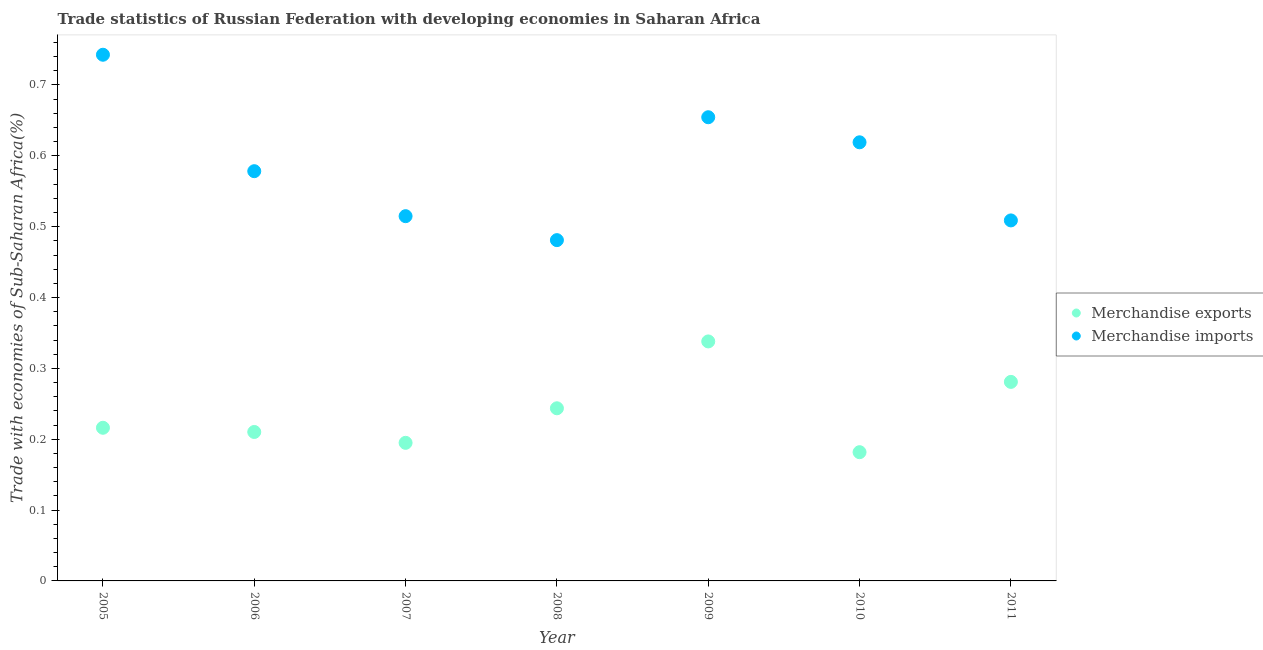How many different coloured dotlines are there?
Ensure brevity in your answer.  2. Is the number of dotlines equal to the number of legend labels?
Your answer should be compact. Yes. What is the merchandise exports in 2005?
Provide a short and direct response. 0.22. Across all years, what is the maximum merchandise imports?
Keep it short and to the point. 0.74. Across all years, what is the minimum merchandise imports?
Provide a short and direct response. 0.48. In which year was the merchandise exports minimum?
Provide a short and direct response. 2010. What is the total merchandise exports in the graph?
Provide a short and direct response. 1.67. What is the difference between the merchandise imports in 2006 and that in 2008?
Your answer should be compact. 0.1. What is the difference between the merchandise imports in 2011 and the merchandise exports in 2009?
Provide a succinct answer. 0.17. What is the average merchandise exports per year?
Provide a succinct answer. 0.24. In the year 2005, what is the difference between the merchandise exports and merchandise imports?
Provide a short and direct response. -0.53. In how many years, is the merchandise imports greater than 0.12000000000000001 %?
Provide a short and direct response. 7. What is the ratio of the merchandise exports in 2006 to that in 2008?
Provide a short and direct response. 0.86. Is the merchandise exports in 2006 less than that in 2008?
Your answer should be compact. Yes. Is the difference between the merchandise imports in 2007 and 2011 greater than the difference between the merchandise exports in 2007 and 2011?
Your response must be concise. Yes. What is the difference between the highest and the second highest merchandise exports?
Offer a very short reply. 0.06. What is the difference between the highest and the lowest merchandise exports?
Provide a short and direct response. 0.16. Is the sum of the merchandise exports in 2007 and 2009 greater than the maximum merchandise imports across all years?
Offer a terse response. No. Does the merchandise imports monotonically increase over the years?
Make the answer very short. No. Is the merchandise imports strictly greater than the merchandise exports over the years?
Give a very brief answer. Yes. Does the graph contain any zero values?
Offer a very short reply. No. How many legend labels are there?
Make the answer very short. 2. What is the title of the graph?
Make the answer very short. Trade statistics of Russian Federation with developing economies in Saharan Africa. What is the label or title of the Y-axis?
Ensure brevity in your answer.  Trade with economies of Sub-Saharan Africa(%). What is the Trade with economies of Sub-Saharan Africa(%) of Merchandise exports in 2005?
Provide a short and direct response. 0.22. What is the Trade with economies of Sub-Saharan Africa(%) of Merchandise imports in 2005?
Your answer should be compact. 0.74. What is the Trade with economies of Sub-Saharan Africa(%) in Merchandise exports in 2006?
Provide a succinct answer. 0.21. What is the Trade with economies of Sub-Saharan Africa(%) of Merchandise imports in 2006?
Keep it short and to the point. 0.58. What is the Trade with economies of Sub-Saharan Africa(%) of Merchandise exports in 2007?
Make the answer very short. 0.19. What is the Trade with economies of Sub-Saharan Africa(%) of Merchandise imports in 2007?
Keep it short and to the point. 0.51. What is the Trade with economies of Sub-Saharan Africa(%) in Merchandise exports in 2008?
Your response must be concise. 0.24. What is the Trade with economies of Sub-Saharan Africa(%) of Merchandise imports in 2008?
Your answer should be very brief. 0.48. What is the Trade with economies of Sub-Saharan Africa(%) of Merchandise exports in 2009?
Your response must be concise. 0.34. What is the Trade with economies of Sub-Saharan Africa(%) of Merchandise imports in 2009?
Offer a terse response. 0.65. What is the Trade with economies of Sub-Saharan Africa(%) in Merchandise exports in 2010?
Provide a succinct answer. 0.18. What is the Trade with economies of Sub-Saharan Africa(%) in Merchandise imports in 2010?
Provide a succinct answer. 0.62. What is the Trade with economies of Sub-Saharan Africa(%) in Merchandise exports in 2011?
Offer a very short reply. 0.28. What is the Trade with economies of Sub-Saharan Africa(%) in Merchandise imports in 2011?
Your answer should be very brief. 0.51. Across all years, what is the maximum Trade with economies of Sub-Saharan Africa(%) in Merchandise exports?
Provide a short and direct response. 0.34. Across all years, what is the maximum Trade with economies of Sub-Saharan Africa(%) of Merchandise imports?
Give a very brief answer. 0.74. Across all years, what is the minimum Trade with economies of Sub-Saharan Africa(%) of Merchandise exports?
Make the answer very short. 0.18. Across all years, what is the minimum Trade with economies of Sub-Saharan Africa(%) of Merchandise imports?
Offer a terse response. 0.48. What is the total Trade with economies of Sub-Saharan Africa(%) in Merchandise exports in the graph?
Offer a very short reply. 1.67. What is the total Trade with economies of Sub-Saharan Africa(%) in Merchandise imports in the graph?
Your response must be concise. 4.1. What is the difference between the Trade with economies of Sub-Saharan Africa(%) of Merchandise exports in 2005 and that in 2006?
Ensure brevity in your answer.  0.01. What is the difference between the Trade with economies of Sub-Saharan Africa(%) of Merchandise imports in 2005 and that in 2006?
Your response must be concise. 0.16. What is the difference between the Trade with economies of Sub-Saharan Africa(%) in Merchandise exports in 2005 and that in 2007?
Ensure brevity in your answer.  0.02. What is the difference between the Trade with economies of Sub-Saharan Africa(%) of Merchandise imports in 2005 and that in 2007?
Your response must be concise. 0.23. What is the difference between the Trade with economies of Sub-Saharan Africa(%) of Merchandise exports in 2005 and that in 2008?
Your answer should be compact. -0.03. What is the difference between the Trade with economies of Sub-Saharan Africa(%) in Merchandise imports in 2005 and that in 2008?
Your answer should be compact. 0.26. What is the difference between the Trade with economies of Sub-Saharan Africa(%) of Merchandise exports in 2005 and that in 2009?
Keep it short and to the point. -0.12. What is the difference between the Trade with economies of Sub-Saharan Africa(%) in Merchandise imports in 2005 and that in 2009?
Keep it short and to the point. 0.09. What is the difference between the Trade with economies of Sub-Saharan Africa(%) in Merchandise exports in 2005 and that in 2010?
Provide a short and direct response. 0.03. What is the difference between the Trade with economies of Sub-Saharan Africa(%) of Merchandise imports in 2005 and that in 2010?
Ensure brevity in your answer.  0.12. What is the difference between the Trade with economies of Sub-Saharan Africa(%) of Merchandise exports in 2005 and that in 2011?
Your answer should be very brief. -0.06. What is the difference between the Trade with economies of Sub-Saharan Africa(%) in Merchandise imports in 2005 and that in 2011?
Offer a terse response. 0.23. What is the difference between the Trade with economies of Sub-Saharan Africa(%) of Merchandise exports in 2006 and that in 2007?
Make the answer very short. 0.02. What is the difference between the Trade with economies of Sub-Saharan Africa(%) in Merchandise imports in 2006 and that in 2007?
Your answer should be compact. 0.06. What is the difference between the Trade with economies of Sub-Saharan Africa(%) in Merchandise exports in 2006 and that in 2008?
Make the answer very short. -0.03. What is the difference between the Trade with economies of Sub-Saharan Africa(%) in Merchandise imports in 2006 and that in 2008?
Give a very brief answer. 0.1. What is the difference between the Trade with economies of Sub-Saharan Africa(%) in Merchandise exports in 2006 and that in 2009?
Your answer should be compact. -0.13. What is the difference between the Trade with economies of Sub-Saharan Africa(%) of Merchandise imports in 2006 and that in 2009?
Your response must be concise. -0.08. What is the difference between the Trade with economies of Sub-Saharan Africa(%) of Merchandise exports in 2006 and that in 2010?
Provide a succinct answer. 0.03. What is the difference between the Trade with economies of Sub-Saharan Africa(%) of Merchandise imports in 2006 and that in 2010?
Offer a terse response. -0.04. What is the difference between the Trade with economies of Sub-Saharan Africa(%) in Merchandise exports in 2006 and that in 2011?
Provide a short and direct response. -0.07. What is the difference between the Trade with economies of Sub-Saharan Africa(%) of Merchandise imports in 2006 and that in 2011?
Provide a short and direct response. 0.07. What is the difference between the Trade with economies of Sub-Saharan Africa(%) of Merchandise exports in 2007 and that in 2008?
Your answer should be compact. -0.05. What is the difference between the Trade with economies of Sub-Saharan Africa(%) of Merchandise imports in 2007 and that in 2008?
Make the answer very short. 0.03. What is the difference between the Trade with economies of Sub-Saharan Africa(%) in Merchandise exports in 2007 and that in 2009?
Your answer should be very brief. -0.14. What is the difference between the Trade with economies of Sub-Saharan Africa(%) in Merchandise imports in 2007 and that in 2009?
Your answer should be very brief. -0.14. What is the difference between the Trade with economies of Sub-Saharan Africa(%) of Merchandise exports in 2007 and that in 2010?
Offer a terse response. 0.01. What is the difference between the Trade with economies of Sub-Saharan Africa(%) in Merchandise imports in 2007 and that in 2010?
Provide a succinct answer. -0.1. What is the difference between the Trade with economies of Sub-Saharan Africa(%) of Merchandise exports in 2007 and that in 2011?
Provide a succinct answer. -0.09. What is the difference between the Trade with economies of Sub-Saharan Africa(%) of Merchandise imports in 2007 and that in 2011?
Provide a succinct answer. 0.01. What is the difference between the Trade with economies of Sub-Saharan Africa(%) in Merchandise exports in 2008 and that in 2009?
Provide a succinct answer. -0.09. What is the difference between the Trade with economies of Sub-Saharan Africa(%) of Merchandise imports in 2008 and that in 2009?
Your answer should be very brief. -0.17. What is the difference between the Trade with economies of Sub-Saharan Africa(%) in Merchandise exports in 2008 and that in 2010?
Offer a very short reply. 0.06. What is the difference between the Trade with economies of Sub-Saharan Africa(%) in Merchandise imports in 2008 and that in 2010?
Offer a terse response. -0.14. What is the difference between the Trade with economies of Sub-Saharan Africa(%) in Merchandise exports in 2008 and that in 2011?
Give a very brief answer. -0.04. What is the difference between the Trade with economies of Sub-Saharan Africa(%) in Merchandise imports in 2008 and that in 2011?
Give a very brief answer. -0.03. What is the difference between the Trade with economies of Sub-Saharan Africa(%) in Merchandise exports in 2009 and that in 2010?
Keep it short and to the point. 0.16. What is the difference between the Trade with economies of Sub-Saharan Africa(%) in Merchandise imports in 2009 and that in 2010?
Your response must be concise. 0.04. What is the difference between the Trade with economies of Sub-Saharan Africa(%) in Merchandise exports in 2009 and that in 2011?
Ensure brevity in your answer.  0.06. What is the difference between the Trade with economies of Sub-Saharan Africa(%) of Merchandise imports in 2009 and that in 2011?
Offer a very short reply. 0.15. What is the difference between the Trade with economies of Sub-Saharan Africa(%) in Merchandise exports in 2010 and that in 2011?
Your response must be concise. -0.1. What is the difference between the Trade with economies of Sub-Saharan Africa(%) of Merchandise imports in 2010 and that in 2011?
Provide a short and direct response. 0.11. What is the difference between the Trade with economies of Sub-Saharan Africa(%) in Merchandise exports in 2005 and the Trade with economies of Sub-Saharan Africa(%) in Merchandise imports in 2006?
Offer a very short reply. -0.36. What is the difference between the Trade with economies of Sub-Saharan Africa(%) in Merchandise exports in 2005 and the Trade with economies of Sub-Saharan Africa(%) in Merchandise imports in 2007?
Provide a succinct answer. -0.3. What is the difference between the Trade with economies of Sub-Saharan Africa(%) in Merchandise exports in 2005 and the Trade with economies of Sub-Saharan Africa(%) in Merchandise imports in 2008?
Your answer should be compact. -0.26. What is the difference between the Trade with economies of Sub-Saharan Africa(%) of Merchandise exports in 2005 and the Trade with economies of Sub-Saharan Africa(%) of Merchandise imports in 2009?
Ensure brevity in your answer.  -0.44. What is the difference between the Trade with economies of Sub-Saharan Africa(%) in Merchandise exports in 2005 and the Trade with economies of Sub-Saharan Africa(%) in Merchandise imports in 2010?
Provide a succinct answer. -0.4. What is the difference between the Trade with economies of Sub-Saharan Africa(%) of Merchandise exports in 2005 and the Trade with economies of Sub-Saharan Africa(%) of Merchandise imports in 2011?
Your answer should be compact. -0.29. What is the difference between the Trade with economies of Sub-Saharan Africa(%) of Merchandise exports in 2006 and the Trade with economies of Sub-Saharan Africa(%) of Merchandise imports in 2007?
Offer a very short reply. -0.3. What is the difference between the Trade with economies of Sub-Saharan Africa(%) of Merchandise exports in 2006 and the Trade with economies of Sub-Saharan Africa(%) of Merchandise imports in 2008?
Your response must be concise. -0.27. What is the difference between the Trade with economies of Sub-Saharan Africa(%) in Merchandise exports in 2006 and the Trade with economies of Sub-Saharan Africa(%) in Merchandise imports in 2009?
Provide a short and direct response. -0.44. What is the difference between the Trade with economies of Sub-Saharan Africa(%) of Merchandise exports in 2006 and the Trade with economies of Sub-Saharan Africa(%) of Merchandise imports in 2010?
Your answer should be compact. -0.41. What is the difference between the Trade with economies of Sub-Saharan Africa(%) in Merchandise exports in 2006 and the Trade with economies of Sub-Saharan Africa(%) in Merchandise imports in 2011?
Provide a short and direct response. -0.3. What is the difference between the Trade with economies of Sub-Saharan Africa(%) in Merchandise exports in 2007 and the Trade with economies of Sub-Saharan Africa(%) in Merchandise imports in 2008?
Offer a terse response. -0.29. What is the difference between the Trade with economies of Sub-Saharan Africa(%) of Merchandise exports in 2007 and the Trade with economies of Sub-Saharan Africa(%) of Merchandise imports in 2009?
Provide a short and direct response. -0.46. What is the difference between the Trade with economies of Sub-Saharan Africa(%) in Merchandise exports in 2007 and the Trade with economies of Sub-Saharan Africa(%) in Merchandise imports in 2010?
Your response must be concise. -0.42. What is the difference between the Trade with economies of Sub-Saharan Africa(%) in Merchandise exports in 2007 and the Trade with economies of Sub-Saharan Africa(%) in Merchandise imports in 2011?
Keep it short and to the point. -0.31. What is the difference between the Trade with economies of Sub-Saharan Africa(%) of Merchandise exports in 2008 and the Trade with economies of Sub-Saharan Africa(%) of Merchandise imports in 2009?
Your answer should be very brief. -0.41. What is the difference between the Trade with economies of Sub-Saharan Africa(%) of Merchandise exports in 2008 and the Trade with economies of Sub-Saharan Africa(%) of Merchandise imports in 2010?
Provide a short and direct response. -0.38. What is the difference between the Trade with economies of Sub-Saharan Africa(%) in Merchandise exports in 2008 and the Trade with economies of Sub-Saharan Africa(%) in Merchandise imports in 2011?
Provide a succinct answer. -0.27. What is the difference between the Trade with economies of Sub-Saharan Africa(%) in Merchandise exports in 2009 and the Trade with economies of Sub-Saharan Africa(%) in Merchandise imports in 2010?
Your answer should be compact. -0.28. What is the difference between the Trade with economies of Sub-Saharan Africa(%) of Merchandise exports in 2009 and the Trade with economies of Sub-Saharan Africa(%) of Merchandise imports in 2011?
Give a very brief answer. -0.17. What is the difference between the Trade with economies of Sub-Saharan Africa(%) in Merchandise exports in 2010 and the Trade with economies of Sub-Saharan Africa(%) in Merchandise imports in 2011?
Give a very brief answer. -0.33. What is the average Trade with economies of Sub-Saharan Africa(%) in Merchandise exports per year?
Give a very brief answer. 0.24. What is the average Trade with economies of Sub-Saharan Africa(%) of Merchandise imports per year?
Ensure brevity in your answer.  0.59. In the year 2005, what is the difference between the Trade with economies of Sub-Saharan Africa(%) of Merchandise exports and Trade with economies of Sub-Saharan Africa(%) of Merchandise imports?
Provide a succinct answer. -0.53. In the year 2006, what is the difference between the Trade with economies of Sub-Saharan Africa(%) in Merchandise exports and Trade with economies of Sub-Saharan Africa(%) in Merchandise imports?
Provide a succinct answer. -0.37. In the year 2007, what is the difference between the Trade with economies of Sub-Saharan Africa(%) of Merchandise exports and Trade with economies of Sub-Saharan Africa(%) of Merchandise imports?
Your answer should be compact. -0.32. In the year 2008, what is the difference between the Trade with economies of Sub-Saharan Africa(%) in Merchandise exports and Trade with economies of Sub-Saharan Africa(%) in Merchandise imports?
Your answer should be very brief. -0.24. In the year 2009, what is the difference between the Trade with economies of Sub-Saharan Africa(%) of Merchandise exports and Trade with economies of Sub-Saharan Africa(%) of Merchandise imports?
Your answer should be very brief. -0.32. In the year 2010, what is the difference between the Trade with economies of Sub-Saharan Africa(%) of Merchandise exports and Trade with economies of Sub-Saharan Africa(%) of Merchandise imports?
Your answer should be compact. -0.44. In the year 2011, what is the difference between the Trade with economies of Sub-Saharan Africa(%) of Merchandise exports and Trade with economies of Sub-Saharan Africa(%) of Merchandise imports?
Provide a succinct answer. -0.23. What is the ratio of the Trade with economies of Sub-Saharan Africa(%) in Merchandise exports in 2005 to that in 2006?
Give a very brief answer. 1.03. What is the ratio of the Trade with economies of Sub-Saharan Africa(%) of Merchandise imports in 2005 to that in 2006?
Provide a succinct answer. 1.28. What is the ratio of the Trade with economies of Sub-Saharan Africa(%) in Merchandise exports in 2005 to that in 2007?
Provide a succinct answer. 1.11. What is the ratio of the Trade with economies of Sub-Saharan Africa(%) in Merchandise imports in 2005 to that in 2007?
Provide a succinct answer. 1.44. What is the ratio of the Trade with economies of Sub-Saharan Africa(%) of Merchandise exports in 2005 to that in 2008?
Ensure brevity in your answer.  0.89. What is the ratio of the Trade with economies of Sub-Saharan Africa(%) in Merchandise imports in 2005 to that in 2008?
Offer a very short reply. 1.54. What is the ratio of the Trade with economies of Sub-Saharan Africa(%) in Merchandise exports in 2005 to that in 2009?
Your response must be concise. 0.64. What is the ratio of the Trade with economies of Sub-Saharan Africa(%) in Merchandise imports in 2005 to that in 2009?
Provide a succinct answer. 1.13. What is the ratio of the Trade with economies of Sub-Saharan Africa(%) of Merchandise exports in 2005 to that in 2010?
Provide a succinct answer. 1.19. What is the ratio of the Trade with economies of Sub-Saharan Africa(%) in Merchandise imports in 2005 to that in 2010?
Provide a succinct answer. 1.2. What is the ratio of the Trade with economies of Sub-Saharan Africa(%) of Merchandise exports in 2005 to that in 2011?
Your response must be concise. 0.77. What is the ratio of the Trade with economies of Sub-Saharan Africa(%) in Merchandise imports in 2005 to that in 2011?
Give a very brief answer. 1.46. What is the ratio of the Trade with economies of Sub-Saharan Africa(%) in Merchandise exports in 2006 to that in 2007?
Give a very brief answer. 1.08. What is the ratio of the Trade with economies of Sub-Saharan Africa(%) in Merchandise imports in 2006 to that in 2007?
Provide a succinct answer. 1.12. What is the ratio of the Trade with economies of Sub-Saharan Africa(%) of Merchandise exports in 2006 to that in 2008?
Give a very brief answer. 0.86. What is the ratio of the Trade with economies of Sub-Saharan Africa(%) in Merchandise imports in 2006 to that in 2008?
Your response must be concise. 1.2. What is the ratio of the Trade with economies of Sub-Saharan Africa(%) in Merchandise exports in 2006 to that in 2009?
Your answer should be compact. 0.62. What is the ratio of the Trade with economies of Sub-Saharan Africa(%) of Merchandise imports in 2006 to that in 2009?
Provide a succinct answer. 0.88. What is the ratio of the Trade with economies of Sub-Saharan Africa(%) in Merchandise exports in 2006 to that in 2010?
Offer a terse response. 1.16. What is the ratio of the Trade with economies of Sub-Saharan Africa(%) in Merchandise imports in 2006 to that in 2010?
Give a very brief answer. 0.93. What is the ratio of the Trade with economies of Sub-Saharan Africa(%) of Merchandise exports in 2006 to that in 2011?
Provide a short and direct response. 0.75. What is the ratio of the Trade with economies of Sub-Saharan Africa(%) in Merchandise imports in 2006 to that in 2011?
Your answer should be very brief. 1.14. What is the ratio of the Trade with economies of Sub-Saharan Africa(%) of Merchandise exports in 2007 to that in 2008?
Your answer should be very brief. 0.8. What is the ratio of the Trade with economies of Sub-Saharan Africa(%) of Merchandise imports in 2007 to that in 2008?
Provide a succinct answer. 1.07. What is the ratio of the Trade with economies of Sub-Saharan Africa(%) of Merchandise exports in 2007 to that in 2009?
Provide a short and direct response. 0.58. What is the ratio of the Trade with economies of Sub-Saharan Africa(%) of Merchandise imports in 2007 to that in 2009?
Make the answer very short. 0.79. What is the ratio of the Trade with economies of Sub-Saharan Africa(%) of Merchandise exports in 2007 to that in 2010?
Your answer should be compact. 1.07. What is the ratio of the Trade with economies of Sub-Saharan Africa(%) of Merchandise imports in 2007 to that in 2010?
Your answer should be compact. 0.83. What is the ratio of the Trade with economies of Sub-Saharan Africa(%) of Merchandise exports in 2007 to that in 2011?
Ensure brevity in your answer.  0.69. What is the ratio of the Trade with economies of Sub-Saharan Africa(%) of Merchandise imports in 2007 to that in 2011?
Give a very brief answer. 1.01. What is the ratio of the Trade with economies of Sub-Saharan Africa(%) in Merchandise exports in 2008 to that in 2009?
Keep it short and to the point. 0.72. What is the ratio of the Trade with economies of Sub-Saharan Africa(%) in Merchandise imports in 2008 to that in 2009?
Ensure brevity in your answer.  0.73. What is the ratio of the Trade with economies of Sub-Saharan Africa(%) of Merchandise exports in 2008 to that in 2010?
Give a very brief answer. 1.34. What is the ratio of the Trade with economies of Sub-Saharan Africa(%) in Merchandise imports in 2008 to that in 2010?
Keep it short and to the point. 0.78. What is the ratio of the Trade with economies of Sub-Saharan Africa(%) of Merchandise exports in 2008 to that in 2011?
Your answer should be very brief. 0.87. What is the ratio of the Trade with economies of Sub-Saharan Africa(%) of Merchandise imports in 2008 to that in 2011?
Provide a short and direct response. 0.95. What is the ratio of the Trade with economies of Sub-Saharan Africa(%) in Merchandise exports in 2009 to that in 2010?
Your response must be concise. 1.86. What is the ratio of the Trade with economies of Sub-Saharan Africa(%) in Merchandise imports in 2009 to that in 2010?
Your response must be concise. 1.06. What is the ratio of the Trade with economies of Sub-Saharan Africa(%) of Merchandise exports in 2009 to that in 2011?
Provide a short and direct response. 1.2. What is the ratio of the Trade with economies of Sub-Saharan Africa(%) of Merchandise imports in 2009 to that in 2011?
Your answer should be very brief. 1.29. What is the ratio of the Trade with economies of Sub-Saharan Africa(%) in Merchandise exports in 2010 to that in 2011?
Ensure brevity in your answer.  0.65. What is the ratio of the Trade with economies of Sub-Saharan Africa(%) in Merchandise imports in 2010 to that in 2011?
Provide a succinct answer. 1.22. What is the difference between the highest and the second highest Trade with economies of Sub-Saharan Africa(%) of Merchandise exports?
Your answer should be compact. 0.06. What is the difference between the highest and the second highest Trade with economies of Sub-Saharan Africa(%) of Merchandise imports?
Give a very brief answer. 0.09. What is the difference between the highest and the lowest Trade with economies of Sub-Saharan Africa(%) of Merchandise exports?
Offer a terse response. 0.16. What is the difference between the highest and the lowest Trade with economies of Sub-Saharan Africa(%) in Merchandise imports?
Provide a short and direct response. 0.26. 